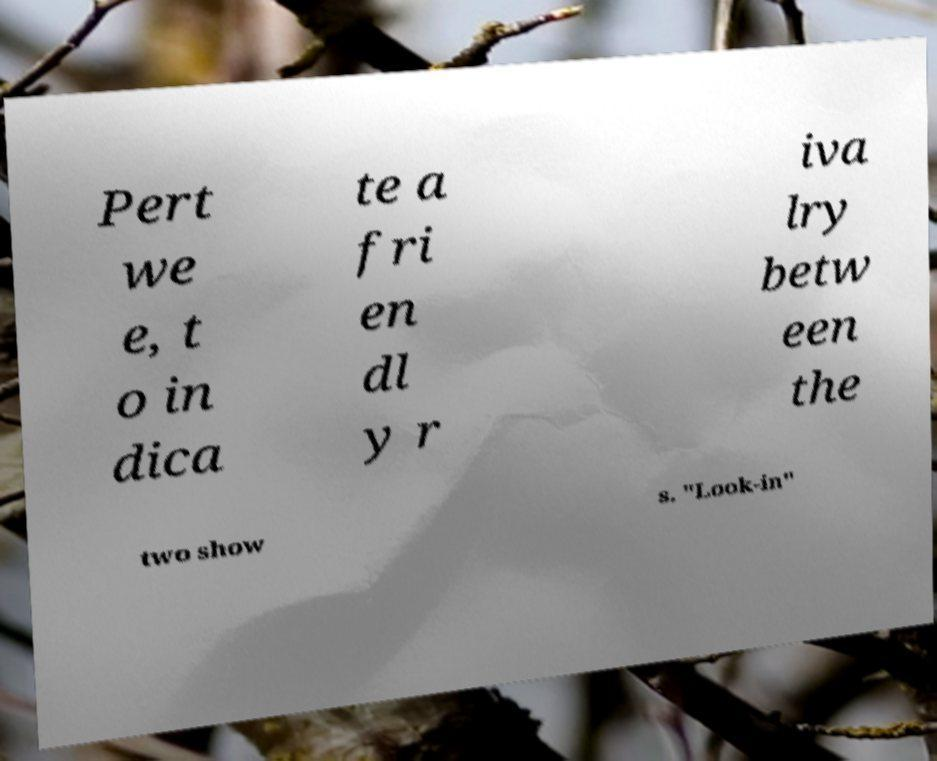For documentation purposes, I need the text within this image transcribed. Could you provide that? Pert we e, t o in dica te a fri en dl y r iva lry betw een the two show s. "Look-in" 